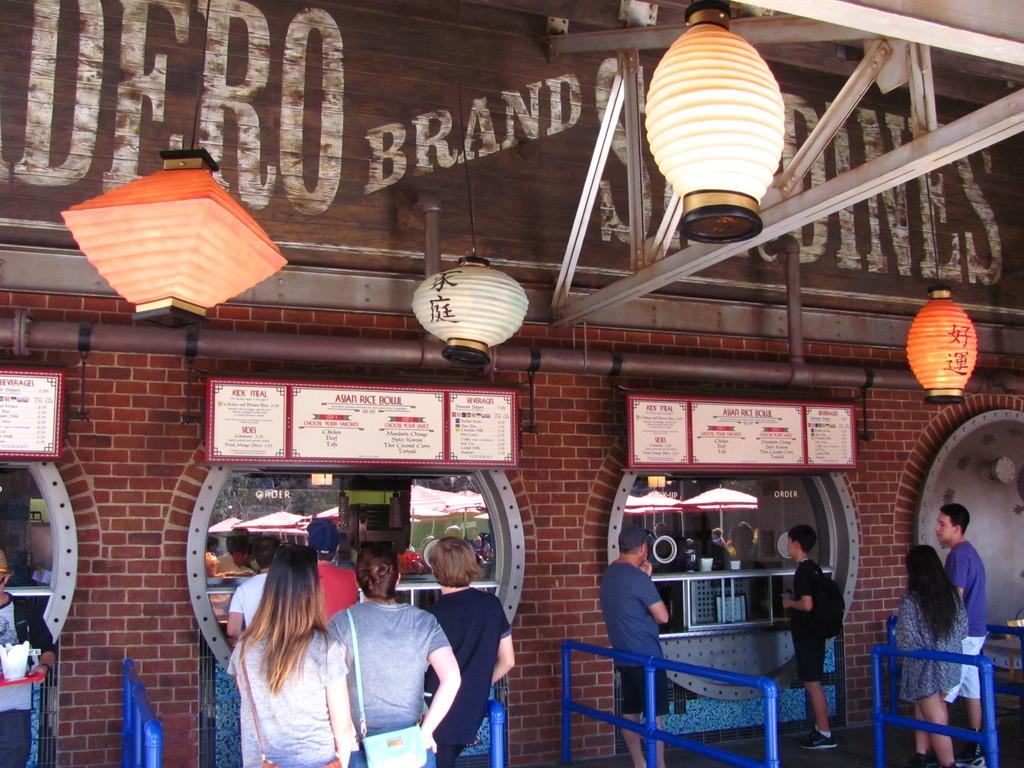Who or what is present in the image? There are people in the image. Where are the people located in the image? The people are standing at the bottom of the image. What can be seen at the top of the image? There are lights at the top of the image. What type of establishment might the image depict? The image appears to depict a store. What type of doll is on fire in the image? There is no doll or fire present in the image. What kind of medical assistance is being provided to the people in the image? There is no indication of medical assistance or a doctor in the image. 